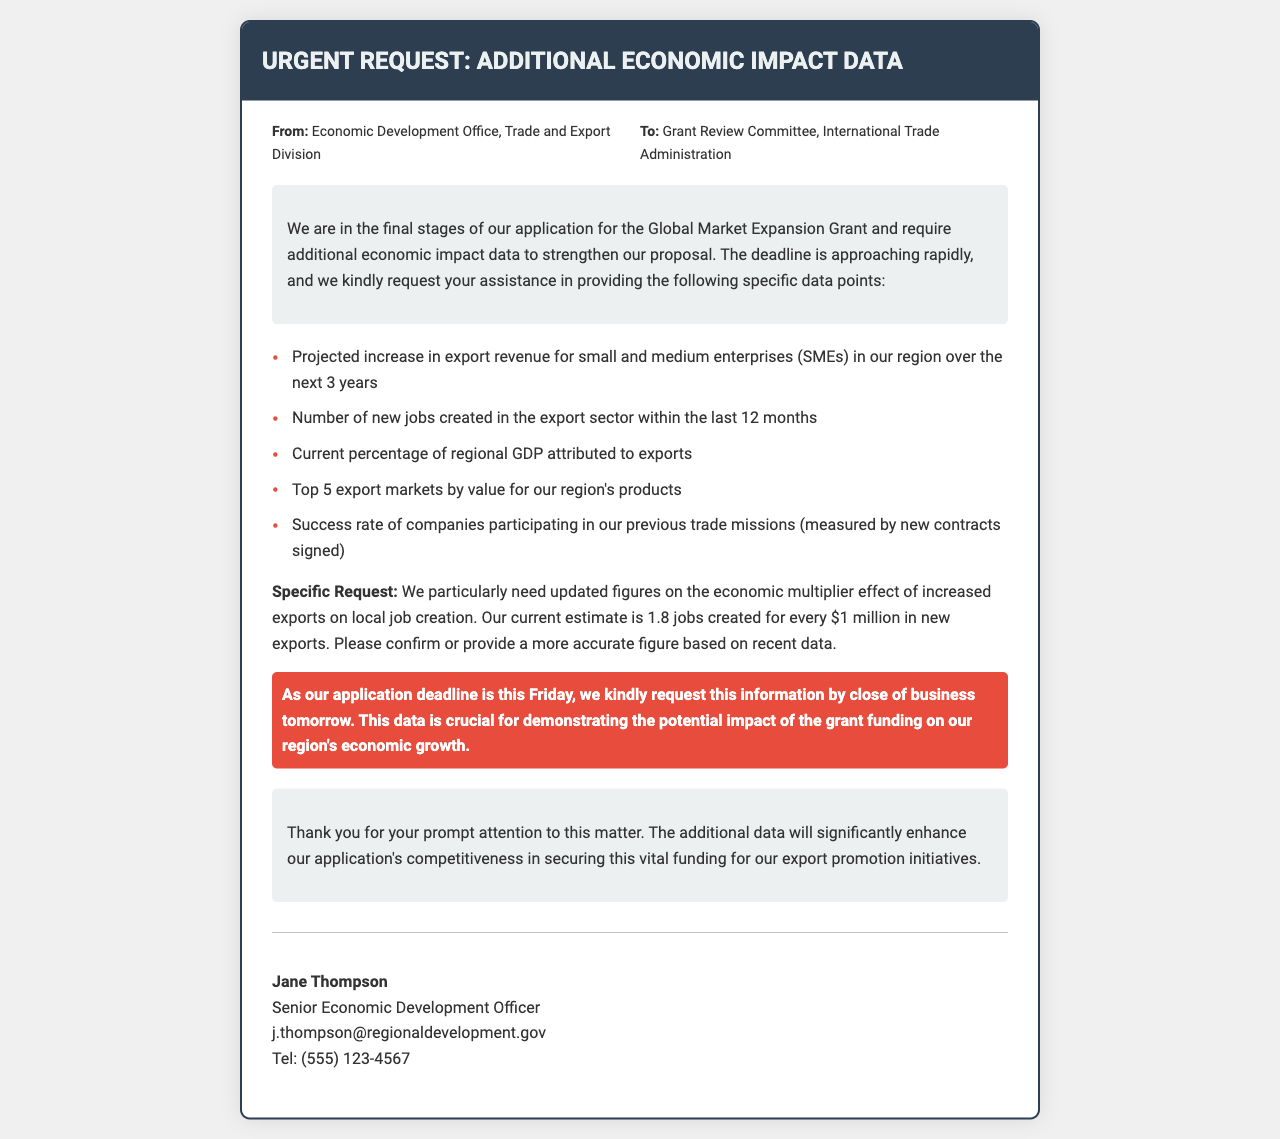What is the title of the fax? The title is stated at the top of the document, indicating the subject matter being addressed.
Answer: Urgent Request: Additional Economic Impact Data Who is the sender of the fax? The sender's information is listed in the document as part of the meta section.
Answer: Economic Development Office, Trade and Export Division What is the specific grant mentioned in the document? The document references a specific grant which is crucial for the request being made.
Answer: Global Market Expansion Grant What is the deadline for the requested information? The urgency of the request is emphasized in the document, including a specific date.
Answer: by close of business tomorrow How many new jobs were created in the export sector within the last year? The document lists this as one of the specific data points needed.
Answer: Number of new jobs created in the export sector is requested, not specifically provided in the text What is the current estimate of the economic multiplier effect mentioned? The document contains a specific estimate regarding the impact of exports on job creation.
Answer: 1.8 jobs created for every $1 million in new exports What are the top five export markets by value? The document requests data on the primary markets for the region's products, indicating significance in the request.
Answer: Top 5 export markets by value is requested, not listed in the text Who is the recipient of the fax? The document clearly indicates to whom the fax is directed in the meta section.
Answer: Grant Review Committee, International Trade Administration What is stated as crucial for demonstrating the potential impact of the grant funding? The conclusion of the fax highlights the importance of the requested data to enhance competitiveness.
Answer: The additional data will significantly enhance our application's competitiveness 